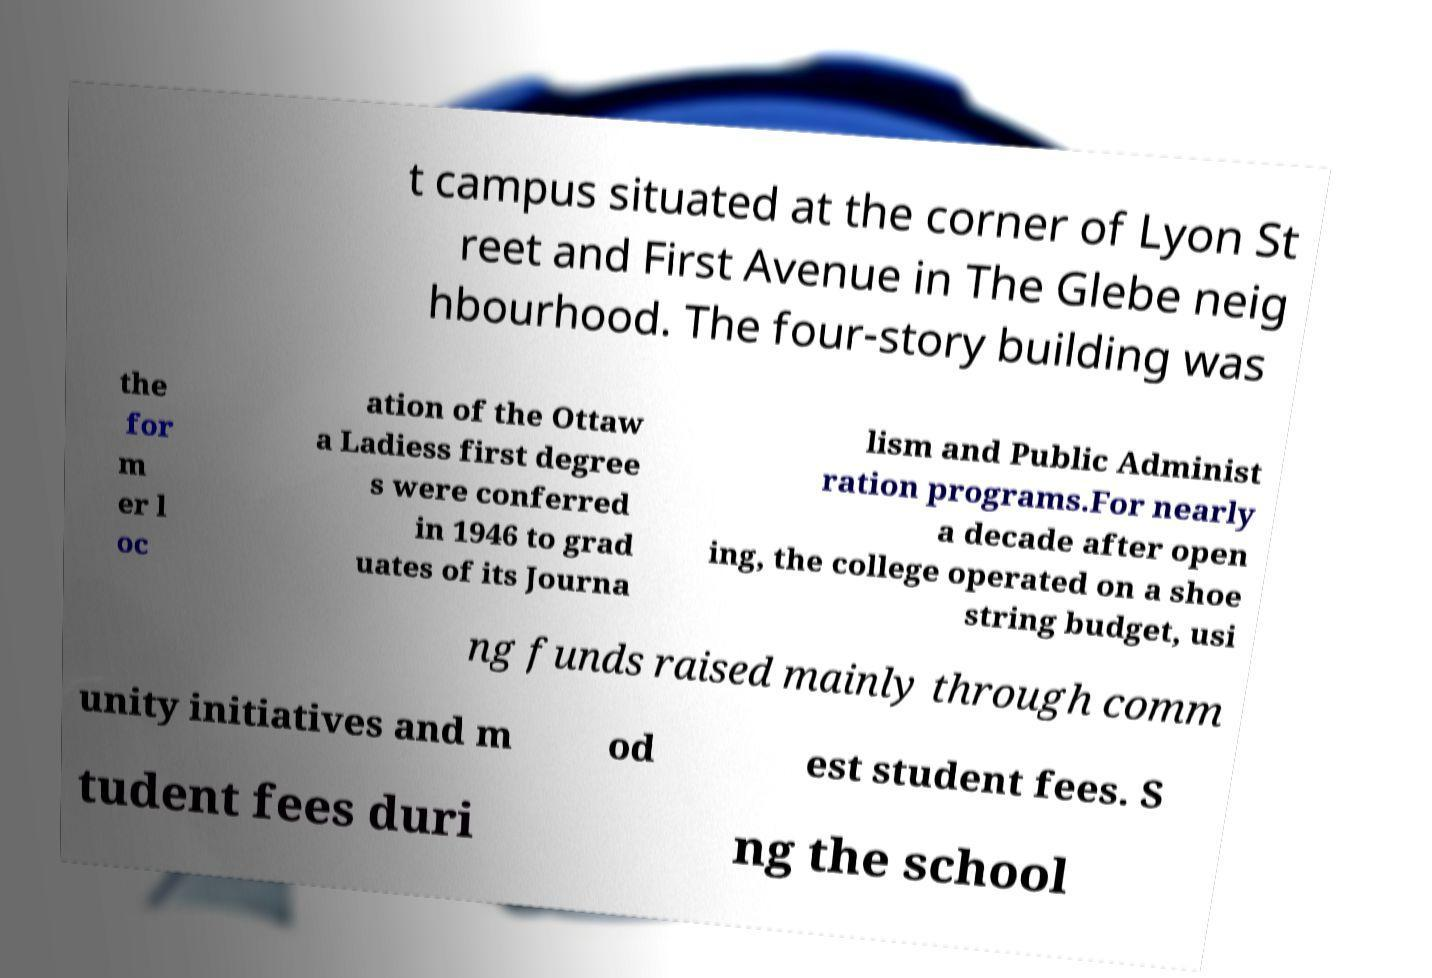Can you read and provide the text displayed in the image?This photo seems to have some interesting text. Can you extract and type it out for me? t campus situated at the corner of Lyon St reet and First Avenue in The Glebe neig hbourhood. The four-story building was the for m er l oc ation of the Ottaw a Ladiess first degree s were conferred in 1946 to grad uates of its Journa lism and Public Administ ration programs.For nearly a decade after open ing, the college operated on a shoe string budget, usi ng funds raised mainly through comm unity initiatives and m od est student fees. S tudent fees duri ng the school 